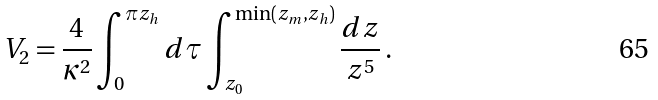<formula> <loc_0><loc_0><loc_500><loc_500>V _ { 2 } = \frac { 4 } { \kappa ^ { 2 } } \int ^ { \pi z _ { h } } _ { 0 } d \tau \int ^ { \min ( z _ { m } , z _ { h } ) } _ { z _ { 0 } } \frac { d z } { z ^ { 5 } } \, .</formula> 